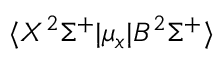Convert formula to latex. <formula><loc_0><loc_0><loc_500><loc_500>\langle X ^ { 2 } \Sigma ^ { + } | \mu _ { x } | B ^ { 2 } \Sigma ^ { + } \rangle</formula> 